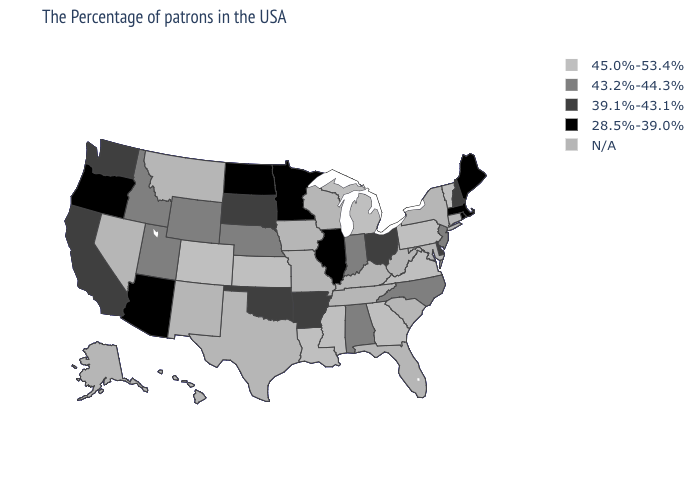Which states hav the highest value in the West?
Quick response, please. Colorado. Which states have the highest value in the USA?
Concise answer only. Vermont, Pennsylvania, Virginia, Georgia, Michigan, Mississippi, Louisiana, Kansas, Colorado. Does the map have missing data?
Give a very brief answer. Yes. What is the value of Connecticut?
Keep it brief. N/A. What is the value of New York?
Short answer required. N/A. Name the states that have a value in the range 45.0%-53.4%?
Concise answer only. Vermont, Pennsylvania, Virginia, Georgia, Michigan, Mississippi, Louisiana, Kansas, Colorado. Name the states that have a value in the range 28.5%-39.0%?
Keep it brief. Maine, Massachusetts, Rhode Island, Illinois, Minnesota, North Dakota, Arizona, Oregon. What is the value of North Dakota?
Short answer required. 28.5%-39.0%. What is the lowest value in states that border Alabama?
Answer briefly. 45.0%-53.4%. Does Massachusetts have the lowest value in the Northeast?
Answer briefly. Yes. Name the states that have a value in the range 39.1%-43.1%?
Short answer required. New Hampshire, Delaware, Ohio, Arkansas, Oklahoma, South Dakota, California, Washington. Name the states that have a value in the range N/A?
Answer briefly. Connecticut, New York, Maryland, South Carolina, West Virginia, Florida, Kentucky, Tennessee, Wisconsin, Missouri, Iowa, Texas, New Mexico, Montana, Nevada, Alaska, Hawaii. Name the states that have a value in the range 39.1%-43.1%?
Concise answer only. New Hampshire, Delaware, Ohio, Arkansas, Oklahoma, South Dakota, California, Washington. 